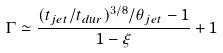Convert formula to latex. <formula><loc_0><loc_0><loc_500><loc_500>\Gamma \simeq \frac { ( t _ { j e t } / t _ { d u r } ) ^ { 3 / 8 } / \theta _ { j e t } - 1 } { 1 - \xi } + 1</formula> 